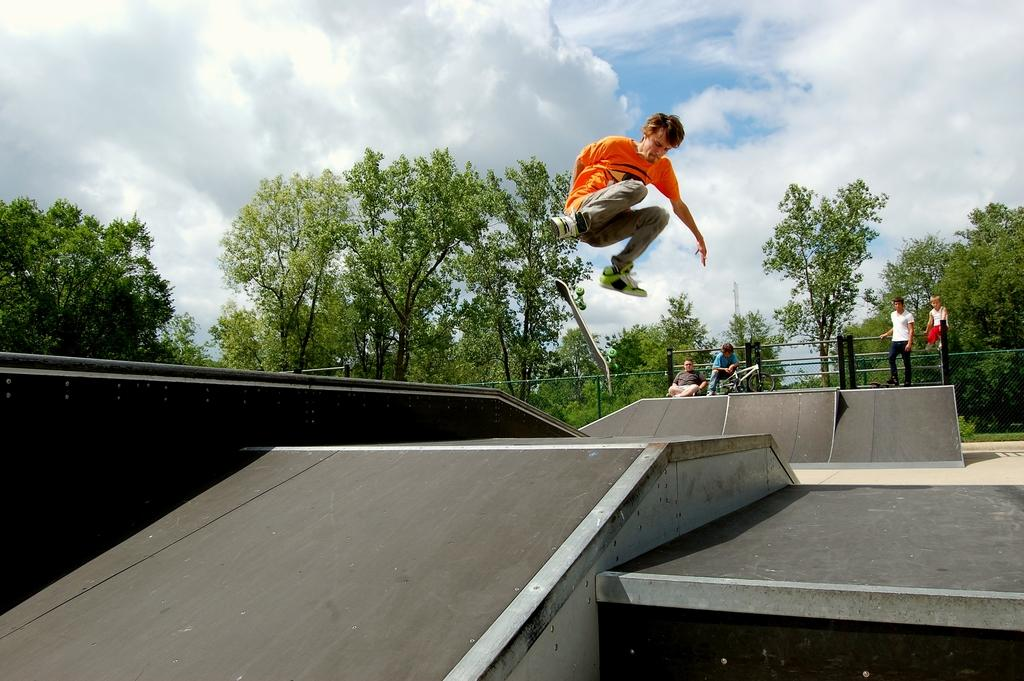How many people are in the image? There are people in the image, but the exact number is not specified. What is the man in the image doing? One man is in the air, which suggests he might be jumping or flying. What can be seen in the background of the image? There are trees, the sky, and a fence visible in the background of the image. What type of fact can be seen in the image? There is no fact visible in the image; it is a scene with people, a man in the air, and a background with trees, the sky, and a fence. Can you tell me how many beetles are crawling on the fence in the image? There are no beetles present in the image; the fence is part of the background and does not have any visible insects. 